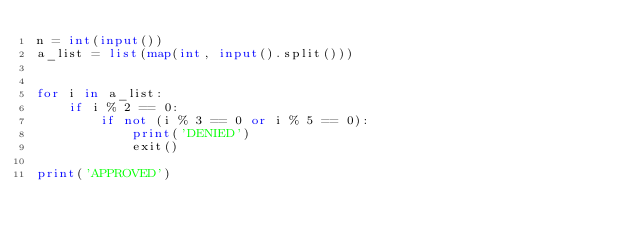<code> <loc_0><loc_0><loc_500><loc_500><_Python_>n = int(input())
a_list = list(map(int, input().split()))


for i in a_list:
    if i % 2 == 0:
        if not (i % 3 == 0 or i % 5 == 0):
            print('DENIED')
            exit()

print('APPROVED')
</code> 